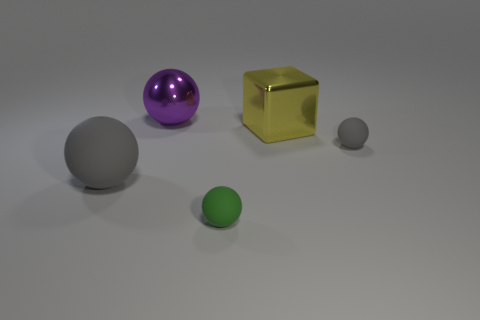Is there anything else that is the same shape as the yellow metal thing?
Keep it short and to the point. No. What number of large yellow blocks are made of the same material as the small green object?
Ensure brevity in your answer.  0. The block that is the same material as the purple sphere is what color?
Make the answer very short. Yellow. Do the small gray object and the large yellow object have the same shape?
Your answer should be compact. No. Are there any big objects behind the gray thing on the right side of the matte sphere in front of the large matte ball?
Your response must be concise. Yes. How many other spheres are the same color as the big rubber sphere?
Keep it short and to the point. 1. There is a yellow shiny object that is the same size as the purple shiny object; what is its shape?
Offer a terse response. Cube. There is a small gray matte object; are there any rubber things to the left of it?
Keep it short and to the point. Yes. Do the green matte ball and the yellow block have the same size?
Provide a short and direct response. No. There is a big shiny thing to the right of the tiny green matte object; what is its shape?
Make the answer very short. Cube. 